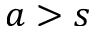<formula> <loc_0><loc_0><loc_500><loc_500>a > s</formula> 